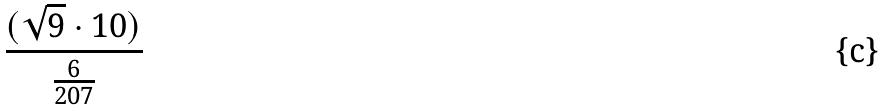Convert formula to latex. <formula><loc_0><loc_0><loc_500><loc_500>\frac { ( \sqrt { 9 } \cdot 1 0 ) } { \frac { 6 } { 2 0 7 } }</formula> 